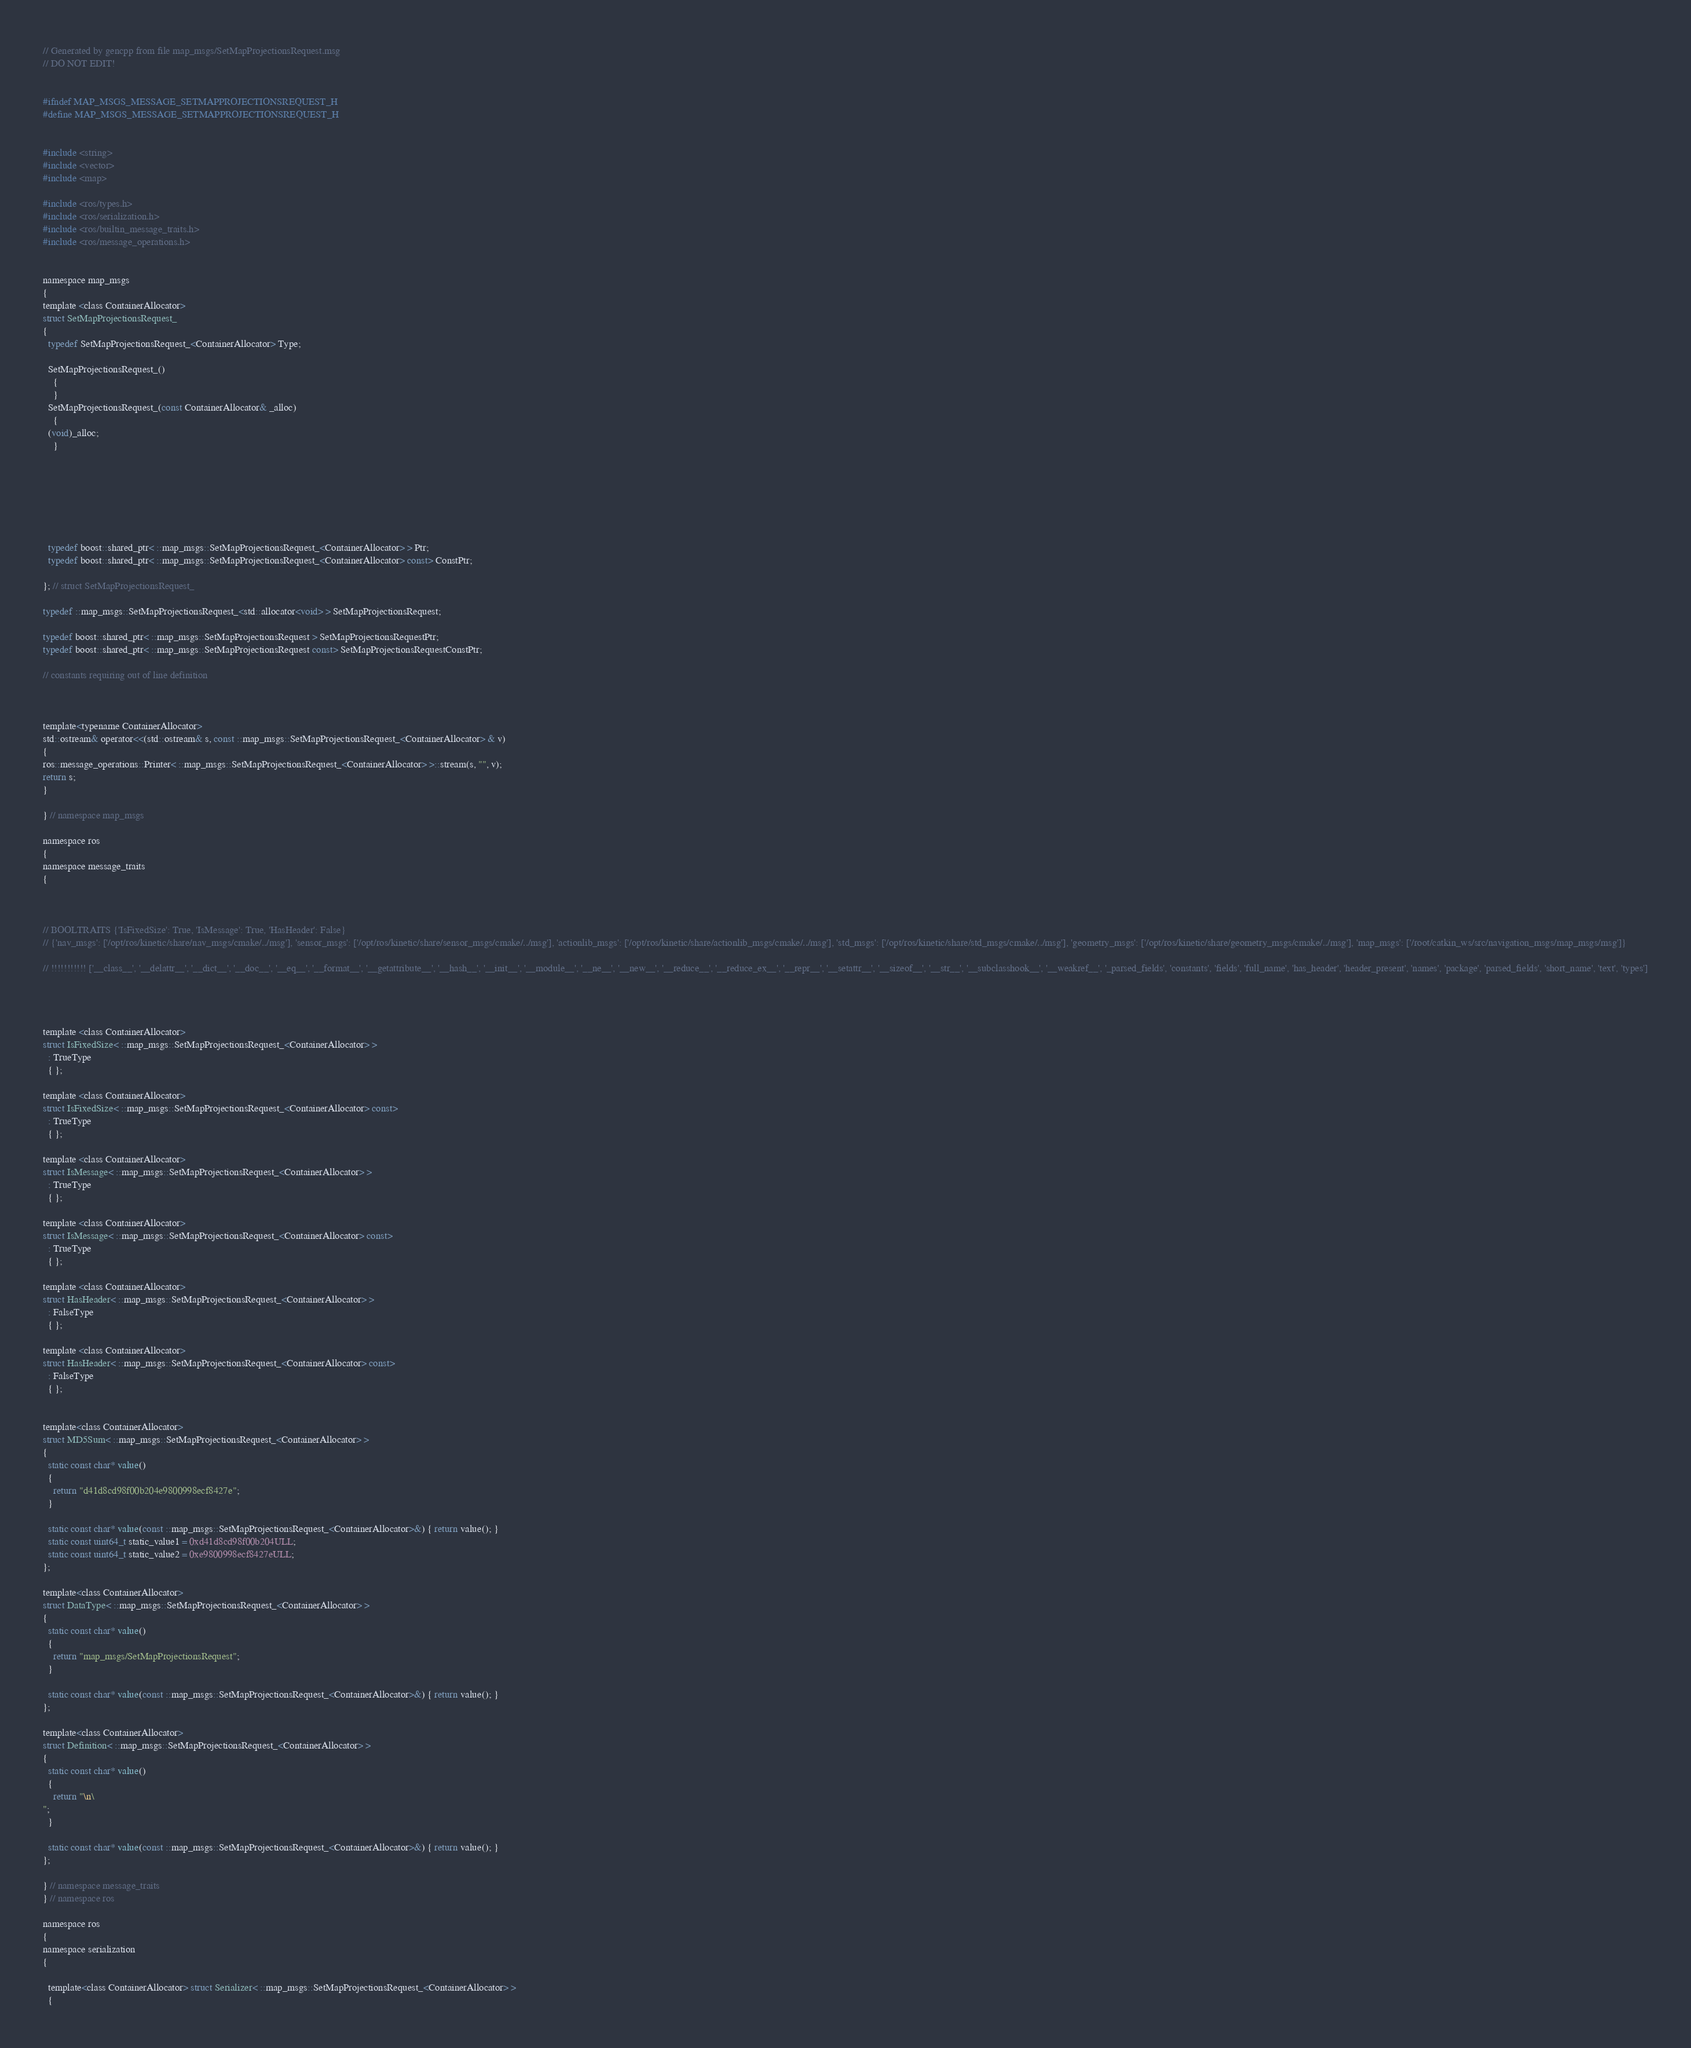<code> <loc_0><loc_0><loc_500><loc_500><_C_>// Generated by gencpp from file map_msgs/SetMapProjectionsRequest.msg
// DO NOT EDIT!


#ifndef MAP_MSGS_MESSAGE_SETMAPPROJECTIONSREQUEST_H
#define MAP_MSGS_MESSAGE_SETMAPPROJECTIONSREQUEST_H


#include <string>
#include <vector>
#include <map>

#include <ros/types.h>
#include <ros/serialization.h>
#include <ros/builtin_message_traits.h>
#include <ros/message_operations.h>


namespace map_msgs
{
template <class ContainerAllocator>
struct SetMapProjectionsRequest_
{
  typedef SetMapProjectionsRequest_<ContainerAllocator> Type;

  SetMapProjectionsRequest_()
    {
    }
  SetMapProjectionsRequest_(const ContainerAllocator& _alloc)
    {
  (void)_alloc;
    }







  typedef boost::shared_ptr< ::map_msgs::SetMapProjectionsRequest_<ContainerAllocator> > Ptr;
  typedef boost::shared_ptr< ::map_msgs::SetMapProjectionsRequest_<ContainerAllocator> const> ConstPtr;

}; // struct SetMapProjectionsRequest_

typedef ::map_msgs::SetMapProjectionsRequest_<std::allocator<void> > SetMapProjectionsRequest;

typedef boost::shared_ptr< ::map_msgs::SetMapProjectionsRequest > SetMapProjectionsRequestPtr;
typedef boost::shared_ptr< ::map_msgs::SetMapProjectionsRequest const> SetMapProjectionsRequestConstPtr;

// constants requiring out of line definition



template<typename ContainerAllocator>
std::ostream& operator<<(std::ostream& s, const ::map_msgs::SetMapProjectionsRequest_<ContainerAllocator> & v)
{
ros::message_operations::Printer< ::map_msgs::SetMapProjectionsRequest_<ContainerAllocator> >::stream(s, "", v);
return s;
}

} // namespace map_msgs

namespace ros
{
namespace message_traits
{



// BOOLTRAITS {'IsFixedSize': True, 'IsMessage': True, 'HasHeader': False}
// {'nav_msgs': ['/opt/ros/kinetic/share/nav_msgs/cmake/../msg'], 'sensor_msgs': ['/opt/ros/kinetic/share/sensor_msgs/cmake/../msg'], 'actionlib_msgs': ['/opt/ros/kinetic/share/actionlib_msgs/cmake/../msg'], 'std_msgs': ['/opt/ros/kinetic/share/std_msgs/cmake/../msg'], 'geometry_msgs': ['/opt/ros/kinetic/share/geometry_msgs/cmake/../msg'], 'map_msgs': ['/root/catkin_ws/src/navigation_msgs/map_msgs/msg']}

// !!!!!!!!!!! ['__class__', '__delattr__', '__dict__', '__doc__', '__eq__', '__format__', '__getattribute__', '__hash__', '__init__', '__module__', '__ne__', '__new__', '__reduce__', '__reduce_ex__', '__repr__', '__setattr__', '__sizeof__', '__str__', '__subclasshook__', '__weakref__', '_parsed_fields', 'constants', 'fields', 'full_name', 'has_header', 'header_present', 'names', 'package', 'parsed_fields', 'short_name', 'text', 'types']




template <class ContainerAllocator>
struct IsFixedSize< ::map_msgs::SetMapProjectionsRequest_<ContainerAllocator> >
  : TrueType
  { };

template <class ContainerAllocator>
struct IsFixedSize< ::map_msgs::SetMapProjectionsRequest_<ContainerAllocator> const>
  : TrueType
  { };

template <class ContainerAllocator>
struct IsMessage< ::map_msgs::SetMapProjectionsRequest_<ContainerAllocator> >
  : TrueType
  { };

template <class ContainerAllocator>
struct IsMessage< ::map_msgs::SetMapProjectionsRequest_<ContainerAllocator> const>
  : TrueType
  { };

template <class ContainerAllocator>
struct HasHeader< ::map_msgs::SetMapProjectionsRequest_<ContainerAllocator> >
  : FalseType
  { };

template <class ContainerAllocator>
struct HasHeader< ::map_msgs::SetMapProjectionsRequest_<ContainerAllocator> const>
  : FalseType
  { };


template<class ContainerAllocator>
struct MD5Sum< ::map_msgs::SetMapProjectionsRequest_<ContainerAllocator> >
{
  static const char* value()
  {
    return "d41d8cd98f00b204e9800998ecf8427e";
  }

  static const char* value(const ::map_msgs::SetMapProjectionsRequest_<ContainerAllocator>&) { return value(); }
  static const uint64_t static_value1 = 0xd41d8cd98f00b204ULL;
  static const uint64_t static_value2 = 0xe9800998ecf8427eULL;
};

template<class ContainerAllocator>
struct DataType< ::map_msgs::SetMapProjectionsRequest_<ContainerAllocator> >
{
  static const char* value()
  {
    return "map_msgs/SetMapProjectionsRequest";
  }

  static const char* value(const ::map_msgs::SetMapProjectionsRequest_<ContainerAllocator>&) { return value(); }
};

template<class ContainerAllocator>
struct Definition< ::map_msgs::SetMapProjectionsRequest_<ContainerAllocator> >
{
  static const char* value()
  {
    return "\n\
";
  }

  static const char* value(const ::map_msgs::SetMapProjectionsRequest_<ContainerAllocator>&) { return value(); }
};

} // namespace message_traits
} // namespace ros

namespace ros
{
namespace serialization
{

  template<class ContainerAllocator> struct Serializer< ::map_msgs::SetMapProjectionsRequest_<ContainerAllocator> >
  {</code> 